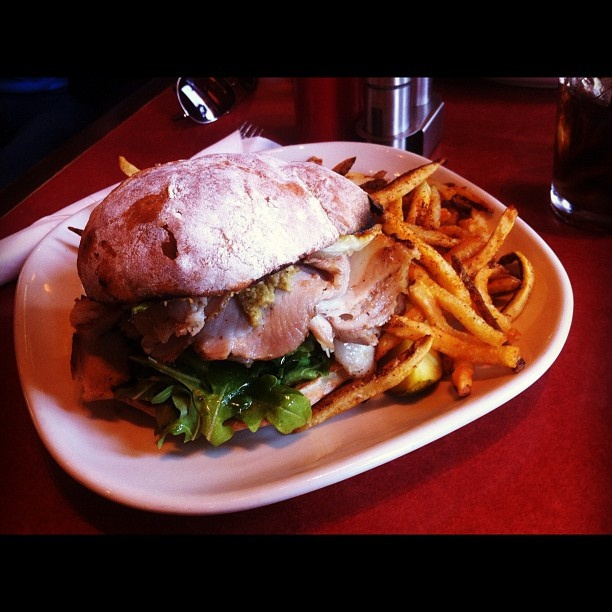Describe the objects in this image and their specific colors. I can see dining table in black, maroon, and lavender tones, sandwich in black, lavender, maroon, and brown tones, cup in black, maroon, lightgray, and purple tones, and fork in black, maroon, purple, and gray tones in this image. 